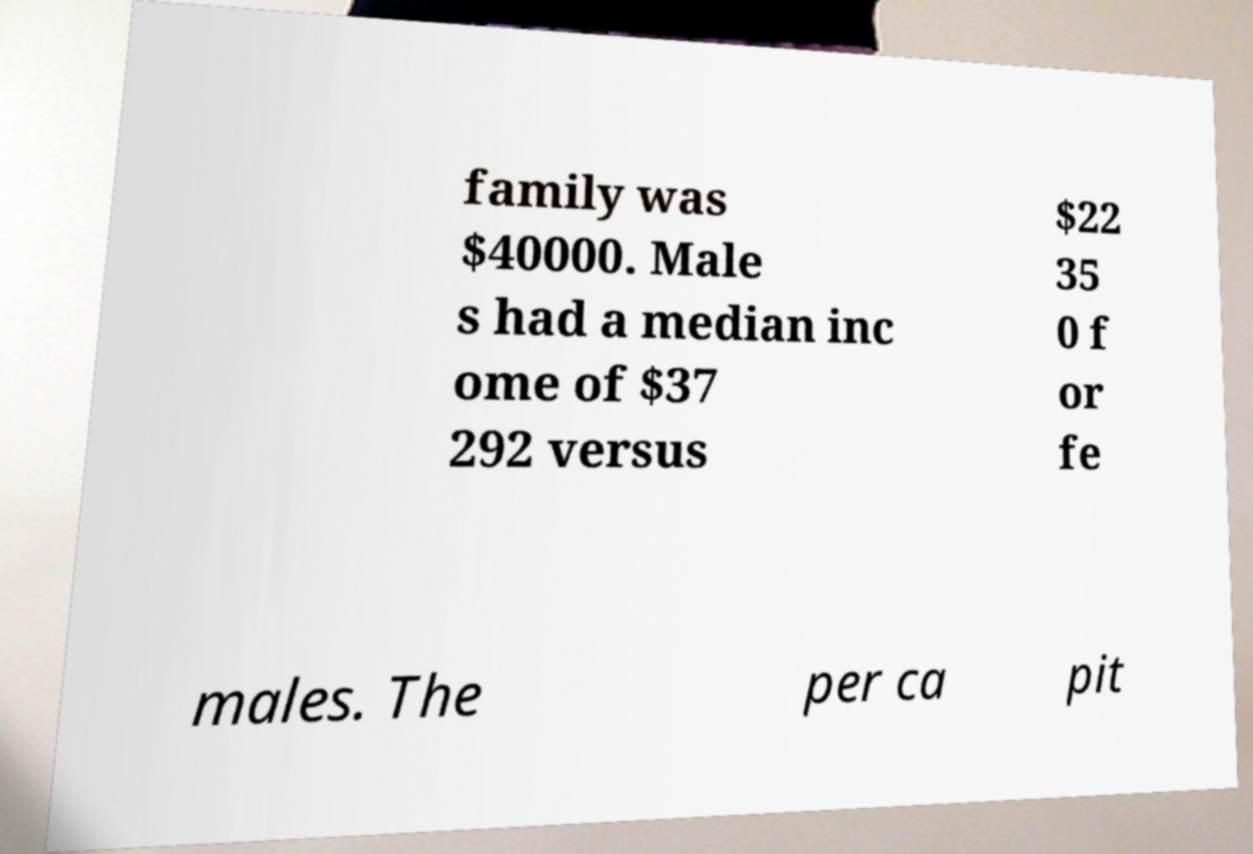Could you extract and type out the text from this image? family was $40000. Male s had a median inc ome of $37 292 versus $22 35 0 f or fe males. The per ca pit 